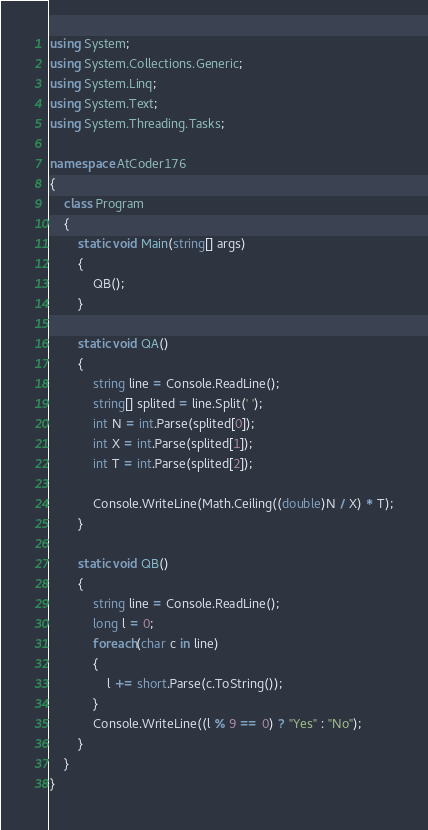Convert code to text. <code><loc_0><loc_0><loc_500><loc_500><_C#_>using System;
using System.Collections.Generic;
using System.Linq;
using System.Text;
using System.Threading.Tasks;

namespace AtCoder176
{
    class Program
    {
        static void Main(string[] args)
        {
            QB();
        }

        static void QA()
        {
            string line = Console.ReadLine();
            string[] splited = line.Split(' ');
            int N = int.Parse(splited[0]);
            int X = int.Parse(splited[1]);
            int T = int.Parse(splited[2]);

            Console.WriteLine(Math.Ceiling((double)N / X) * T);
        }

        static void QB()
        {
            string line = Console.ReadLine();
            long l = 0;
            foreach(char c in line)
            {
                l += short.Parse(c.ToString());
            }
            Console.WriteLine((l % 9 == 0) ? "Yes" : "No");
        }
    }
}
</code> 